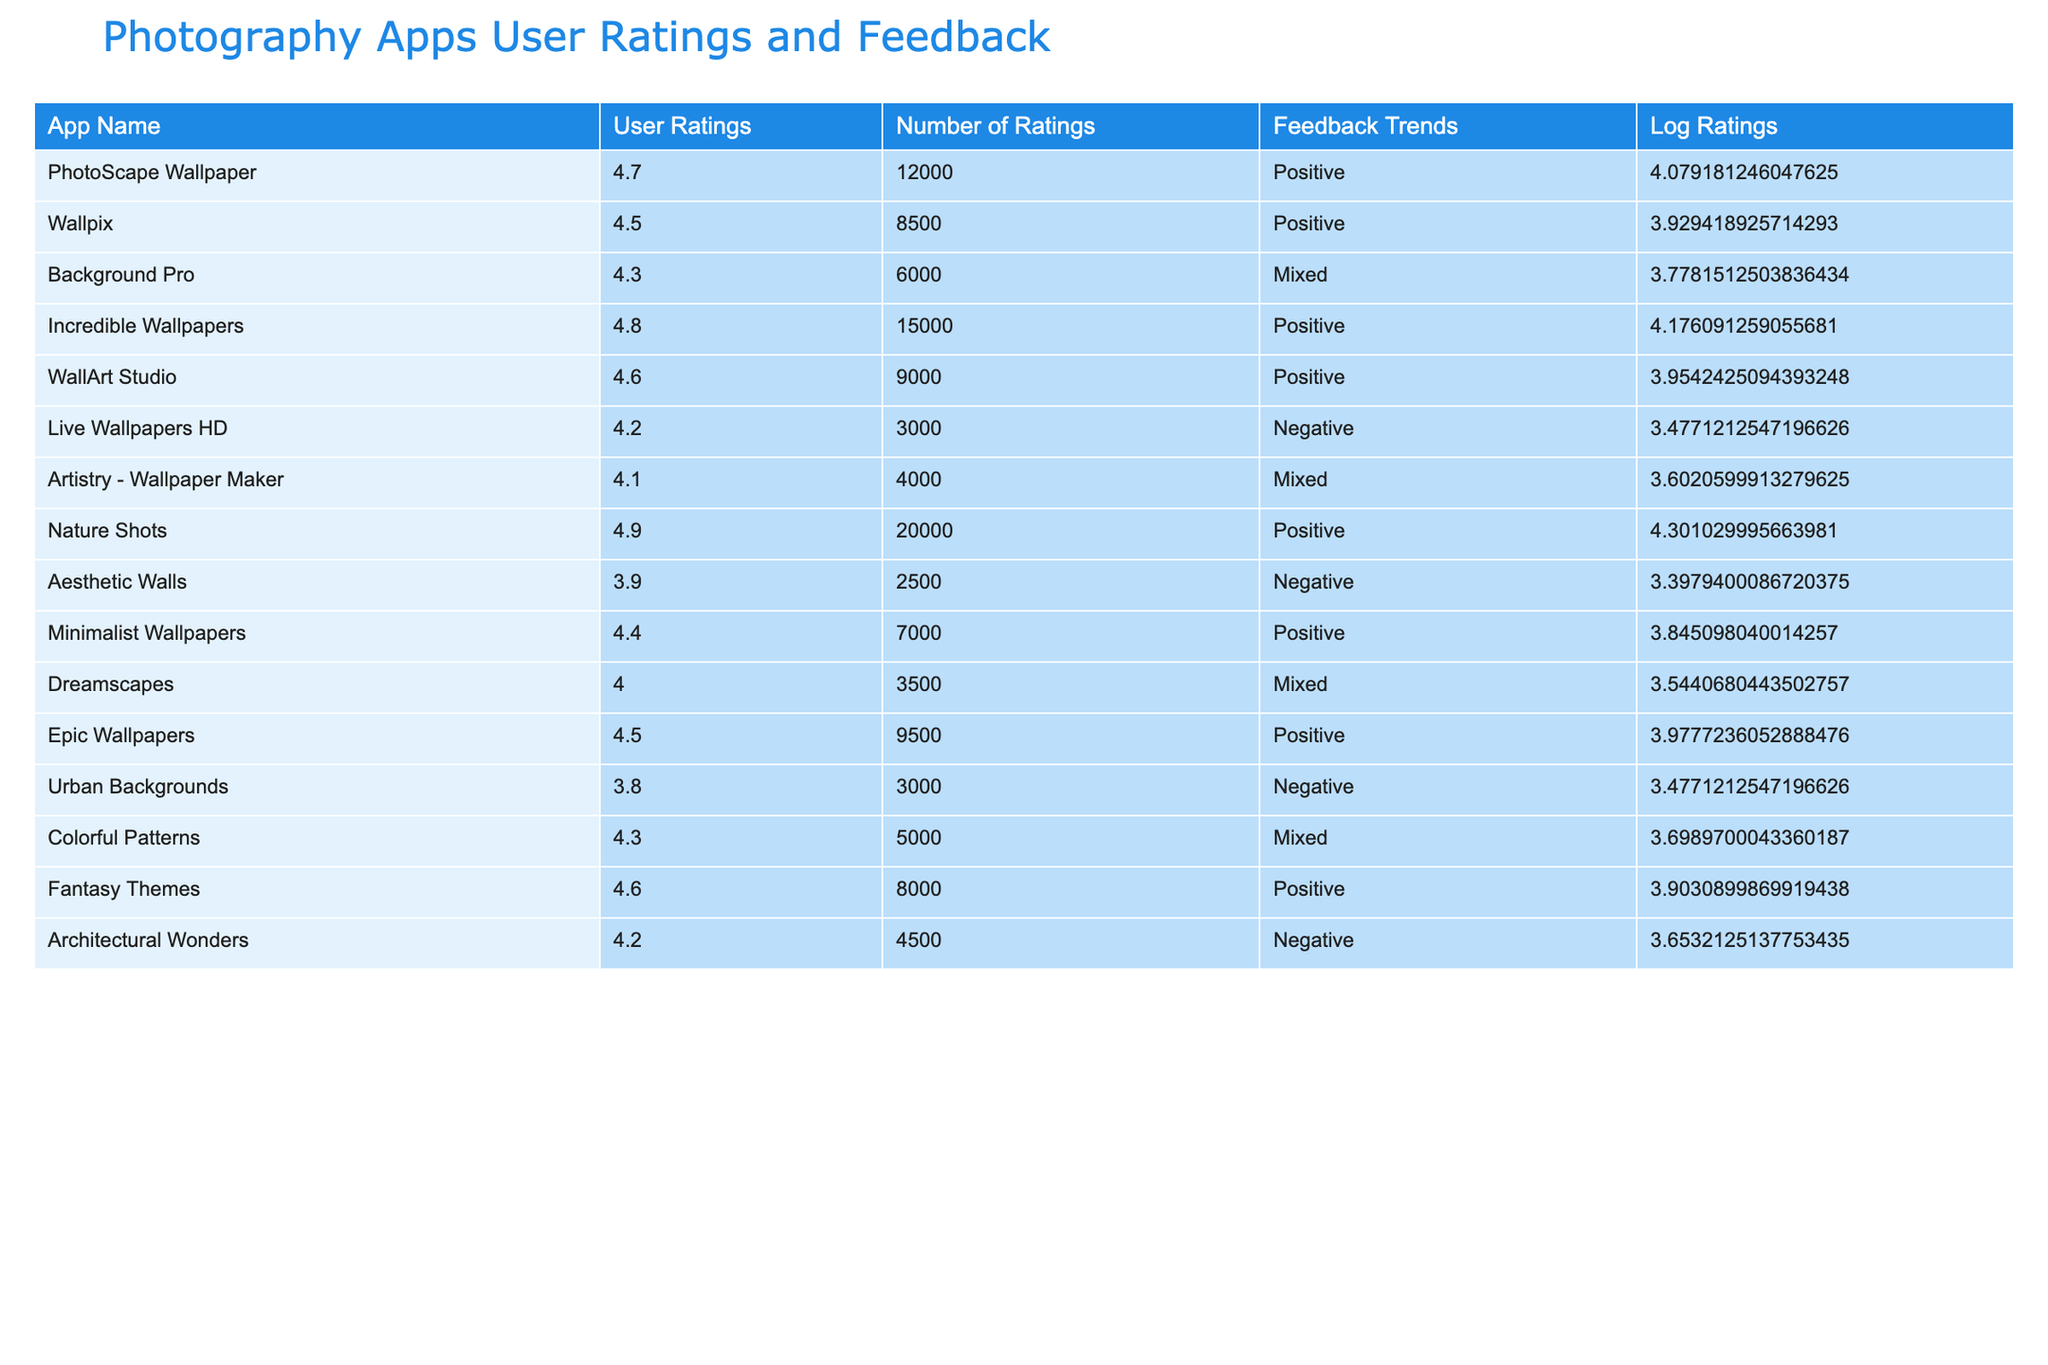What is the user rating of Nature Shots? The user rating for Nature Shots is directly listed in the table under the "User Ratings" column. It shows a value of 4.9.
Answer: 4.9 How many ratings does Live Wallpapers HD have? The number of ratings for Live Wallpapers HD is explicitly stated in the "Number of Ratings" column, which shows a value of 3000.
Answer: 3000 Which app has the most number of ratings? To determine this, we look at the "Number of Ratings" column and compare all values. Nature Shots has 20000 ratings, which is the highest noted in the table.
Answer: Nature Shots Is the feedback trend for Architectural Wonders positive? By checking the "Feedback Trends" column for Architectural Wonders, we see that it is categorized as Negative, thus the statement is false.
Answer: No What is the average user rating of apps with Mixed feedback? We first identify the user ratings of apps with Mixed feedback: Background Pro (4.3), Artistry - Wallpaper Maker (4.1), Colorful Patterns (4.3), and Dreamscapes (4.0). Adding these ratings gives us 4.3 + 4.1 + 4.3 + 4.0 = 16.7. To find the average, we divide by the number of apps (4), which results in 16.7 / 4 = 4.175.
Answer: 4.175 Which apps have a user rating of 4.6 or higher and positive feedback? We filter out the apps with a rating of 4.6 or higher in the "User Ratings" column: Incredible Wallpapers (4.8), Fantasy Themes (4.6), Nature Shots (4.9), WallArt Studio (4.6), and Epic Wallpapers (4.5), and see that all of these have a positive feedback trend.
Answer: Incredible Wallpapers, Fantasy Themes, Nature Shots, WallArt Studio, Epic Wallpapers What is the difference in user ratings between the highest and lowest-rated apps? The highest user rating is for Nature Shots at 4.9, and the lowest is for Aesthetic Walls at 3.9. The difference is calculated by subtracting the lowest rating from the highest: 4.9 - 3.9 = 1.0.
Answer: 1.0 Which app has more ratings: Wallpix or Minimalist Wallpapers? By comparing the "Number of Ratings," Wallpix has 8500 and Minimalist Wallpapers has 7000. 8500 is greater than 7000.
Answer: Wallpix Do any apps have a user rating of 4.0 or below? Looking through the "User Ratings" column, we check the values and see that Aesthetic Walls (3.9), Urban Backgrounds (3.8), and Dreamscapes (4.0) have ratings at or below 4.0. Thus, the answer is yes.
Answer: Yes 